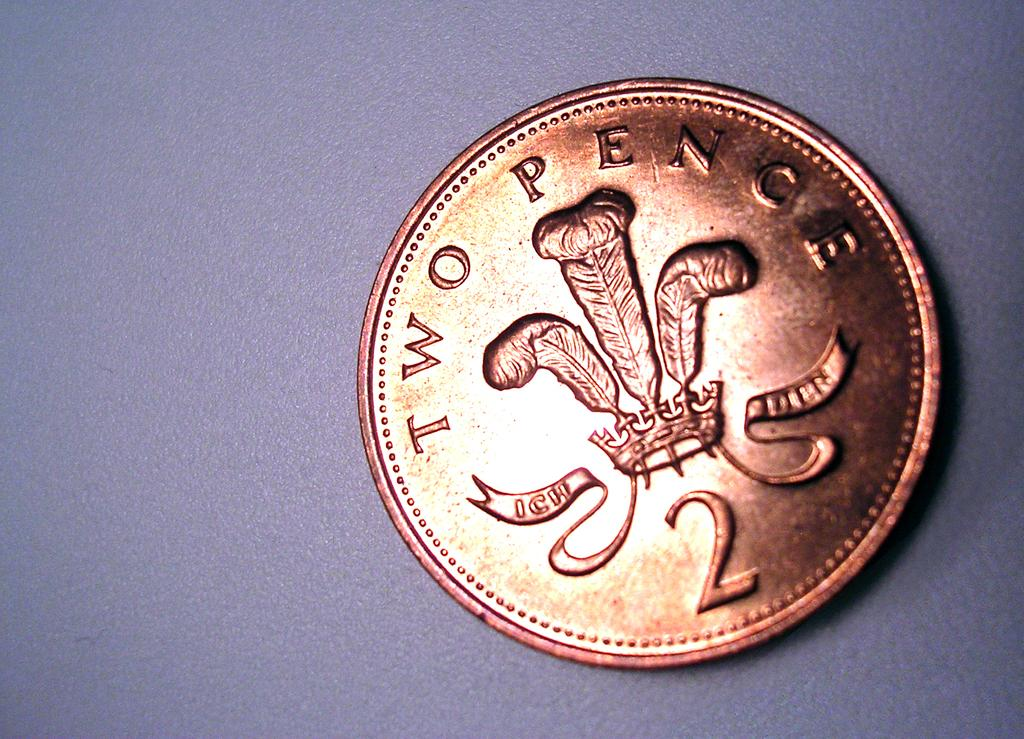<image>
Provide a brief description of the given image. A bronze coin that has the number 2 at the bottom and is worth two pence. 